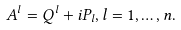<formula> <loc_0><loc_0><loc_500><loc_500>A ^ { l } = Q ^ { l } + i P _ { l } , l = 1 , \dots , n .</formula> 